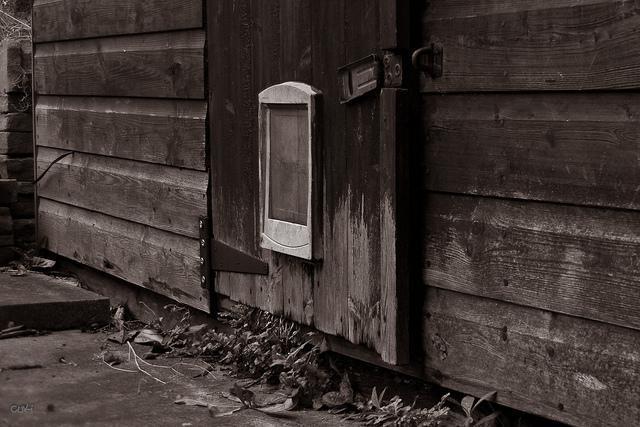How many people are wearing glasses in this scene?
Give a very brief answer. 0. 